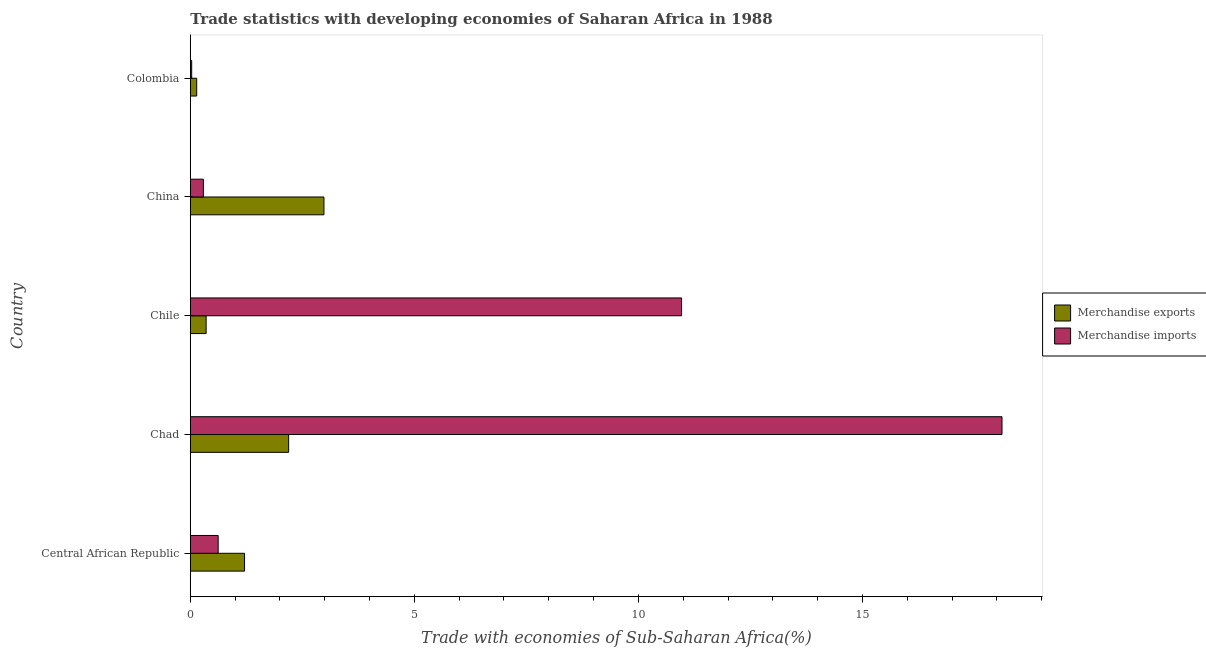How many different coloured bars are there?
Provide a short and direct response. 2. How many bars are there on the 5th tick from the bottom?
Provide a short and direct response. 2. What is the merchandise imports in Central African Republic?
Ensure brevity in your answer.  0.62. Across all countries, what is the maximum merchandise imports?
Make the answer very short. 18.11. Across all countries, what is the minimum merchandise exports?
Provide a short and direct response. 0.14. In which country was the merchandise exports maximum?
Your answer should be compact. China. What is the total merchandise exports in the graph?
Provide a succinct answer. 6.88. What is the difference between the merchandise imports in Central African Republic and that in Chile?
Offer a terse response. -10.34. What is the difference between the merchandise exports in Central African Republic and the merchandise imports in Chad?
Make the answer very short. -16.9. What is the average merchandise exports per country?
Your answer should be very brief. 1.38. What is the difference between the merchandise imports and merchandise exports in Central African Republic?
Give a very brief answer. -0.59. What is the ratio of the merchandise exports in Central African Republic to that in Chile?
Give a very brief answer. 3.43. Is the merchandise exports in China less than that in Colombia?
Your answer should be very brief. No. What is the difference between the highest and the second highest merchandise imports?
Your answer should be compact. 7.15. What is the difference between the highest and the lowest merchandise imports?
Give a very brief answer. 18.08. In how many countries, is the merchandise imports greater than the average merchandise imports taken over all countries?
Provide a succinct answer. 2. Is the sum of the merchandise imports in Chad and China greater than the maximum merchandise exports across all countries?
Your answer should be very brief. Yes. What does the 1st bar from the top in Colombia represents?
Provide a succinct answer. Merchandise imports. What does the 2nd bar from the bottom in Chile represents?
Provide a short and direct response. Merchandise imports. Are all the bars in the graph horizontal?
Give a very brief answer. Yes. Are the values on the major ticks of X-axis written in scientific E-notation?
Your answer should be very brief. No. Does the graph contain any zero values?
Keep it short and to the point. No. Where does the legend appear in the graph?
Keep it short and to the point. Center right. How many legend labels are there?
Provide a succinct answer. 2. How are the legend labels stacked?
Ensure brevity in your answer.  Vertical. What is the title of the graph?
Your response must be concise. Trade statistics with developing economies of Saharan Africa in 1988. Does "Underweight" appear as one of the legend labels in the graph?
Make the answer very short. No. What is the label or title of the X-axis?
Offer a terse response. Trade with economies of Sub-Saharan Africa(%). What is the label or title of the Y-axis?
Offer a very short reply. Country. What is the Trade with economies of Sub-Saharan Africa(%) of Merchandise exports in Central African Republic?
Offer a terse response. 1.21. What is the Trade with economies of Sub-Saharan Africa(%) of Merchandise imports in Central African Republic?
Offer a very short reply. 0.62. What is the Trade with economies of Sub-Saharan Africa(%) of Merchandise exports in Chad?
Provide a short and direct response. 2.19. What is the Trade with economies of Sub-Saharan Africa(%) in Merchandise imports in Chad?
Your response must be concise. 18.11. What is the Trade with economies of Sub-Saharan Africa(%) in Merchandise exports in Chile?
Your answer should be very brief. 0.35. What is the Trade with economies of Sub-Saharan Africa(%) in Merchandise imports in Chile?
Your response must be concise. 10.96. What is the Trade with economies of Sub-Saharan Africa(%) in Merchandise exports in China?
Provide a succinct answer. 2.98. What is the Trade with economies of Sub-Saharan Africa(%) in Merchandise imports in China?
Offer a terse response. 0.29. What is the Trade with economies of Sub-Saharan Africa(%) in Merchandise exports in Colombia?
Provide a short and direct response. 0.14. What is the Trade with economies of Sub-Saharan Africa(%) of Merchandise imports in Colombia?
Your answer should be very brief. 0.03. Across all countries, what is the maximum Trade with economies of Sub-Saharan Africa(%) in Merchandise exports?
Keep it short and to the point. 2.98. Across all countries, what is the maximum Trade with economies of Sub-Saharan Africa(%) of Merchandise imports?
Give a very brief answer. 18.11. Across all countries, what is the minimum Trade with economies of Sub-Saharan Africa(%) of Merchandise exports?
Offer a very short reply. 0.14. Across all countries, what is the minimum Trade with economies of Sub-Saharan Africa(%) of Merchandise imports?
Ensure brevity in your answer.  0.03. What is the total Trade with economies of Sub-Saharan Africa(%) in Merchandise exports in the graph?
Give a very brief answer. 6.88. What is the total Trade with economies of Sub-Saharan Africa(%) of Merchandise imports in the graph?
Ensure brevity in your answer.  30.02. What is the difference between the Trade with economies of Sub-Saharan Africa(%) of Merchandise exports in Central African Republic and that in Chad?
Provide a short and direct response. -0.98. What is the difference between the Trade with economies of Sub-Saharan Africa(%) of Merchandise imports in Central African Republic and that in Chad?
Make the answer very short. -17.49. What is the difference between the Trade with economies of Sub-Saharan Africa(%) in Merchandise exports in Central African Republic and that in Chile?
Make the answer very short. 0.86. What is the difference between the Trade with economies of Sub-Saharan Africa(%) in Merchandise imports in Central African Republic and that in Chile?
Your answer should be compact. -10.34. What is the difference between the Trade with economies of Sub-Saharan Africa(%) in Merchandise exports in Central African Republic and that in China?
Offer a very short reply. -1.77. What is the difference between the Trade with economies of Sub-Saharan Africa(%) of Merchandise imports in Central African Republic and that in China?
Offer a very short reply. 0.33. What is the difference between the Trade with economies of Sub-Saharan Africa(%) of Merchandise exports in Central African Republic and that in Colombia?
Offer a very short reply. 1.07. What is the difference between the Trade with economies of Sub-Saharan Africa(%) of Merchandise imports in Central African Republic and that in Colombia?
Keep it short and to the point. 0.59. What is the difference between the Trade with economies of Sub-Saharan Africa(%) in Merchandise exports in Chad and that in Chile?
Offer a very short reply. 1.84. What is the difference between the Trade with economies of Sub-Saharan Africa(%) of Merchandise imports in Chad and that in Chile?
Your answer should be compact. 7.15. What is the difference between the Trade with economies of Sub-Saharan Africa(%) in Merchandise exports in Chad and that in China?
Give a very brief answer. -0.79. What is the difference between the Trade with economies of Sub-Saharan Africa(%) in Merchandise imports in Chad and that in China?
Provide a short and direct response. 17.82. What is the difference between the Trade with economies of Sub-Saharan Africa(%) of Merchandise exports in Chad and that in Colombia?
Your response must be concise. 2.05. What is the difference between the Trade with economies of Sub-Saharan Africa(%) in Merchandise imports in Chad and that in Colombia?
Provide a short and direct response. 18.08. What is the difference between the Trade with economies of Sub-Saharan Africa(%) of Merchandise exports in Chile and that in China?
Provide a short and direct response. -2.63. What is the difference between the Trade with economies of Sub-Saharan Africa(%) in Merchandise imports in Chile and that in China?
Offer a very short reply. 10.67. What is the difference between the Trade with economies of Sub-Saharan Africa(%) in Merchandise exports in Chile and that in Colombia?
Offer a very short reply. 0.21. What is the difference between the Trade with economies of Sub-Saharan Africa(%) in Merchandise imports in Chile and that in Colombia?
Your response must be concise. 10.93. What is the difference between the Trade with economies of Sub-Saharan Africa(%) of Merchandise exports in China and that in Colombia?
Make the answer very short. 2.84. What is the difference between the Trade with economies of Sub-Saharan Africa(%) in Merchandise imports in China and that in Colombia?
Ensure brevity in your answer.  0.26. What is the difference between the Trade with economies of Sub-Saharan Africa(%) in Merchandise exports in Central African Republic and the Trade with economies of Sub-Saharan Africa(%) in Merchandise imports in Chad?
Provide a succinct answer. -16.9. What is the difference between the Trade with economies of Sub-Saharan Africa(%) of Merchandise exports in Central African Republic and the Trade with economies of Sub-Saharan Africa(%) of Merchandise imports in Chile?
Keep it short and to the point. -9.75. What is the difference between the Trade with economies of Sub-Saharan Africa(%) of Merchandise exports in Central African Republic and the Trade with economies of Sub-Saharan Africa(%) of Merchandise imports in China?
Offer a very short reply. 0.92. What is the difference between the Trade with economies of Sub-Saharan Africa(%) in Merchandise exports in Central African Republic and the Trade with economies of Sub-Saharan Africa(%) in Merchandise imports in Colombia?
Provide a short and direct response. 1.18. What is the difference between the Trade with economies of Sub-Saharan Africa(%) in Merchandise exports in Chad and the Trade with economies of Sub-Saharan Africa(%) in Merchandise imports in Chile?
Offer a very short reply. -8.77. What is the difference between the Trade with economies of Sub-Saharan Africa(%) of Merchandise exports in Chad and the Trade with economies of Sub-Saharan Africa(%) of Merchandise imports in China?
Your answer should be compact. 1.9. What is the difference between the Trade with economies of Sub-Saharan Africa(%) of Merchandise exports in Chad and the Trade with economies of Sub-Saharan Africa(%) of Merchandise imports in Colombia?
Give a very brief answer. 2.16. What is the difference between the Trade with economies of Sub-Saharan Africa(%) of Merchandise exports in Chile and the Trade with economies of Sub-Saharan Africa(%) of Merchandise imports in China?
Provide a succinct answer. 0.06. What is the difference between the Trade with economies of Sub-Saharan Africa(%) of Merchandise exports in Chile and the Trade with economies of Sub-Saharan Africa(%) of Merchandise imports in Colombia?
Offer a very short reply. 0.32. What is the difference between the Trade with economies of Sub-Saharan Africa(%) of Merchandise exports in China and the Trade with economies of Sub-Saharan Africa(%) of Merchandise imports in Colombia?
Your answer should be compact. 2.95. What is the average Trade with economies of Sub-Saharan Africa(%) in Merchandise exports per country?
Ensure brevity in your answer.  1.38. What is the average Trade with economies of Sub-Saharan Africa(%) in Merchandise imports per country?
Keep it short and to the point. 6. What is the difference between the Trade with economies of Sub-Saharan Africa(%) of Merchandise exports and Trade with economies of Sub-Saharan Africa(%) of Merchandise imports in Central African Republic?
Ensure brevity in your answer.  0.59. What is the difference between the Trade with economies of Sub-Saharan Africa(%) in Merchandise exports and Trade with economies of Sub-Saharan Africa(%) in Merchandise imports in Chad?
Your answer should be compact. -15.92. What is the difference between the Trade with economies of Sub-Saharan Africa(%) in Merchandise exports and Trade with economies of Sub-Saharan Africa(%) in Merchandise imports in Chile?
Keep it short and to the point. -10.61. What is the difference between the Trade with economies of Sub-Saharan Africa(%) in Merchandise exports and Trade with economies of Sub-Saharan Africa(%) in Merchandise imports in China?
Offer a terse response. 2.69. What is the difference between the Trade with economies of Sub-Saharan Africa(%) of Merchandise exports and Trade with economies of Sub-Saharan Africa(%) of Merchandise imports in Colombia?
Your answer should be very brief. 0.11. What is the ratio of the Trade with economies of Sub-Saharan Africa(%) in Merchandise exports in Central African Republic to that in Chad?
Provide a short and direct response. 0.55. What is the ratio of the Trade with economies of Sub-Saharan Africa(%) of Merchandise imports in Central African Republic to that in Chad?
Make the answer very short. 0.03. What is the ratio of the Trade with economies of Sub-Saharan Africa(%) of Merchandise exports in Central African Republic to that in Chile?
Your answer should be compact. 3.43. What is the ratio of the Trade with economies of Sub-Saharan Africa(%) of Merchandise imports in Central African Republic to that in Chile?
Keep it short and to the point. 0.06. What is the ratio of the Trade with economies of Sub-Saharan Africa(%) in Merchandise exports in Central African Republic to that in China?
Provide a succinct answer. 0.41. What is the ratio of the Trade with economies of Sub-Saharan Africa(%) in Merchandise imports in Central African Republic to that in China?
Offer a terse response. 2.13. What is the ratio of the Trade with economies of Sub-Saharan Africa(%) in Merchandise exports in Central African Republic to that in Colombia?
Give a very brief answer. 8.48. What is the ratio of the Trade with economies of Sub-Saharan Africa(%) in Merchandise imports in Central African Republic to that in Colombia?
Keep it short and to the point. 19.95. What is the ratio of the Trade with economies of Sub-Saharan Africa(%) of Merchandise exports in Chad to that in Chile?
Keep it short and to the point. 6.21. What is the ratio of the Trade with economies of Sub-Saharan Africa(%) of Merchandise imports in Chad to that in Chile?
Give a very brief answer. 1.65. What is the ratio of the Trade with economies of Sub-Saharan Africa(%) in Merchandise exports in Chad to that in China?
Your response must be concise. 0.74. What is the ratio of the Trade with economies of Sub-Saharan Africa(%) of Merchandise imports in Chad to that in China?
Your answer should be very brief. 62.05. What is the ratio of the Trade with economies of Sub-Saharan Africa(%) of Merchandise exports in Chad to that in Colombia?
Your answer should be very brief. 15.36. What is the ratio of the Trade with economies of Sub-Saharan Africa(%) in Merchandise imports in Chad to that in Colombia?
Make the answer very short. 581.11. What is the ratio of the Trade with economies of Sub-Saharan Africa(%) in Merchandise exports in Chile to that in China?
Your answer should be compact. 0.12. What is the ratio of the Trade with economies of Sub-Saharan Africa(%) in Merchandise imports in Chile to that in China?
Make the answer very short. 37.55. What is the ratio of the Trade with economies of Sub-Saharan Africa(%) of Merchandise exports in Chile to that in Colombia?
Your answer should be compact. 2.47. What is the ratio of the Trade with economies of Sub-Saharan Africa(%) of Merchandise imports in Chile to that in Colombia?
Your response must be concise. 351.7. What is the ratio of the Trade with economies of Sub-Saharan Africa(%) of Merchandise exports in China to that in Colombia?
Provide a succinct answer. 20.88. What is the ratio of the Trade with economies of Sub-Saharan Africa(%) in Merchandise imports in China to that in Colombia?
Offer a terse response. 9.37. What is the difference between the highest and the second highest Trade with economies of Sub-Saharan Africa(%) in Merchandise exports?
Keep it short and to the point. 0.79. What is the difference between the highest and the second highest Trade with economies of Sub-Saharan Africa(%) in Merchandise imports?
Ensure brevity in your answer.  7.15. What is the difference between the highest and the lowest Trade with economies of Sub-Saharan Africa(%) of Merchandise exports?
Your answer should be very brief. 2.84. What is the difference between the highest and the lowest Trade with economies of Sub-Saharan Africa(%) in Merchandise imports?
Your response must be concise. 18.08. 